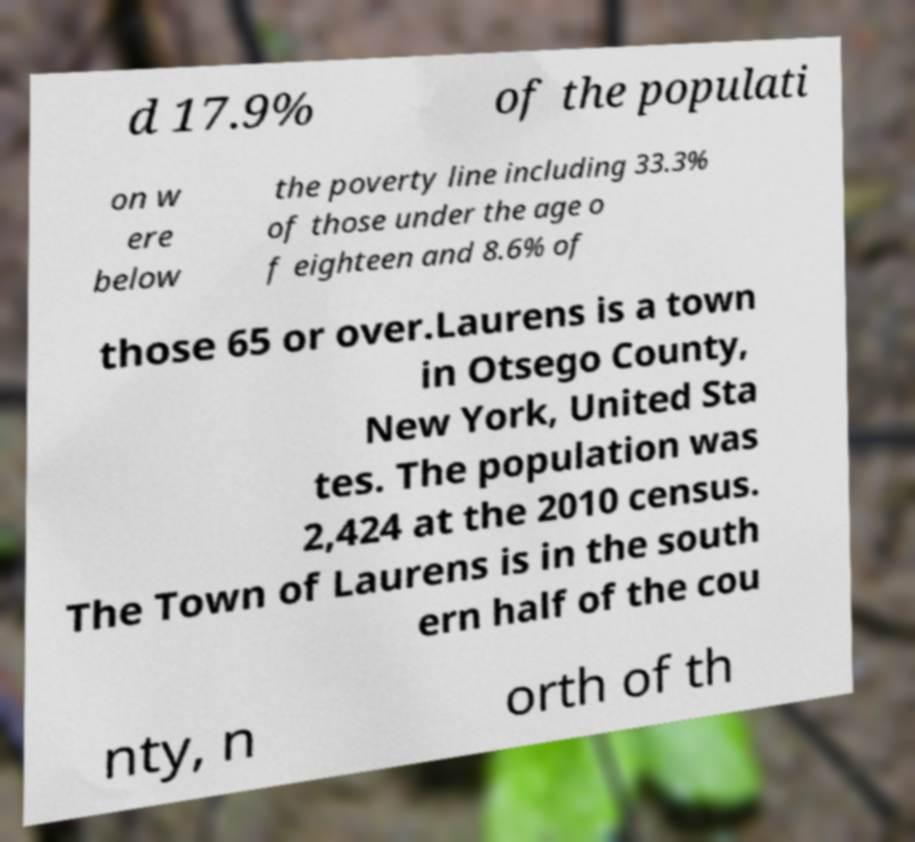Could you assist in decoding the text presented in this image and type it out clearly? d 17.9% of the populati on w ere below the poverty line including 33.3% of those under the age o f eighteen and 8.6% of those 65 or over.Laurens is a town in Otsego County, New York, United Sta tes. The population was 2,424 at the 2010 census. The Town of Laurens is in the south ern half of the cou nty, n orth of th 